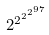<formula> <loc_0><loc_0><loc_500><loc_500>2 ^ { 2 ^ { 2 ^ { 2 ^ { 9 7 } } } }</formula> 